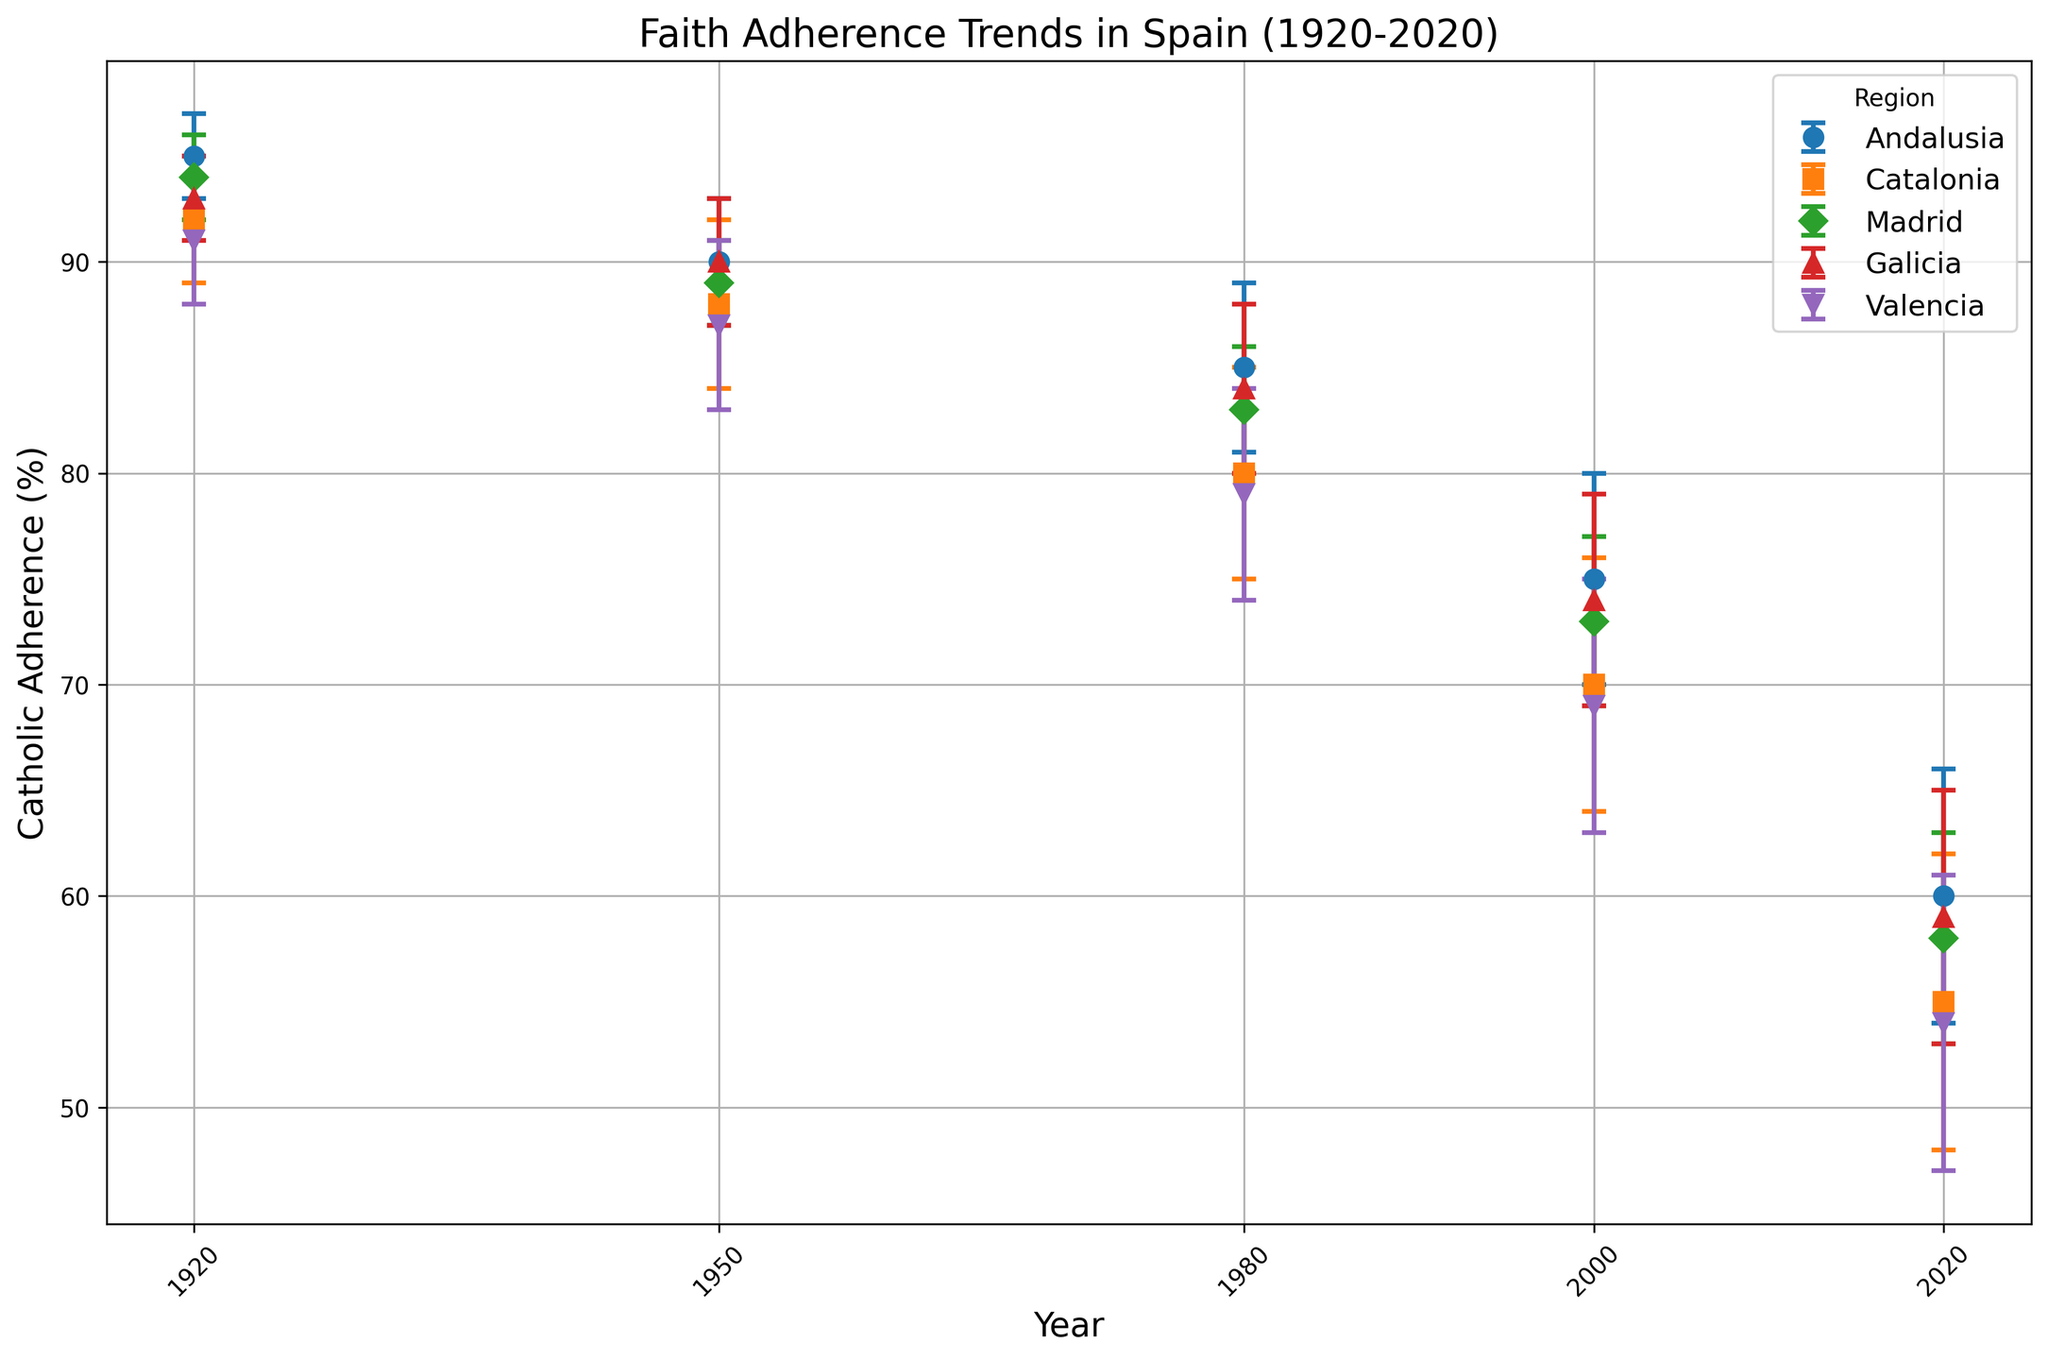Which region experienced the largest decrease in Catholic adherence between 1920 and 2020? Examine the error bars for each region in 1920 and 2020 and calculate the difference in Catholic adherence values. Andalusia decreased from 95 to 60, Catalonia from 92 to 55, Madrid from 94 to 58, Galicia from 93 to 59, and Valencia from 91 to 54. The largest decrease is found in Catalonia, dropping by 37 percentage points.
Answer: Catalonia Which region had the highest Catholic adherence in 1920? Look at the data points in 1920 for each region. Andalusia had 95, Catalonia had 92, Madrid had 94, Galicia had 93, and Valencia had 91. The highest adherence is in Andalusia.
Answer: Andalusia What is the average Catholic adherence in 2000 across all regions? Sum the Catholic adherence values for all regions in 2000 and divide by the number of regions. The values are 75 (Andalusia), 70 (Catalonia), 73 (Madrid), 74 (Galicia), and 69 (Valencia). Sum is 75 + 70 + 73 + 74 + 69 = 361. Divide 361 by 5 to obtain the average.
Answer: 72.2 Comparing Galicia and Madrid, which has a higher adherence in 1980 and by how much? Look at the adherence values for Galicia and Madrid in 1980. Galicia has 84 and Madrid has 83. Calculate the difference, 84 - 83.
Answer: Galicia by 1 Which two regions have the closest adherence values in 1950? Look at the adherence values for all regions in 1950. Andalusia had 90, Catalonia had 88, Madrid had 89, Galicia had 90, and Valencia had 87. The closest adherence values are between Andalusia and Galicia, both having 90.
Answer: Andalusia and Galicia By how much did Catholic adherence in Madrid decrease from 1950 to 1980? Look at the adherence values for Madrid in 1950 and 1980. In 1950, Madrid had 89 and in 1980, it had 83. Calculate the difference, 89 - 83.
Answer: 6 Which region had the least change in Catholic adherence from 1950 to 2000? Calculate the difference in adherence values for each region between 1950 and 2000: Andalusia (90-75=15), Catalonia (88-70=18), Madrid (89-73=16), Galicia (90-74=16), Valencia (87-69=18). The least change is in Andalusia with a difference of 15.
Answer: Andalusia In 2020, which region had the highest error margin and what is the value? Look at the error margins for all regions in 2020. The values are as follows: Andalusia (6), Catalonia (7), Madrid (5), Galicia (6), and Valencia (7). The highest error margin is found in Catalonia and Valencia, both with a value of 7.
Answer: Catalonia and Valencia Between 1920 and 1950, which region saw a greater relative decrease in Catholic adherence, Andalusia or Valencia? Calculate the percentage decrease for both regions. For Andalusia: (95-90)/95*100 = 5.26%. For Valencia: (91-87)/91*100 = 4.40%. The greater relative decrease is in Andalusia.
Answer: Andalusia 